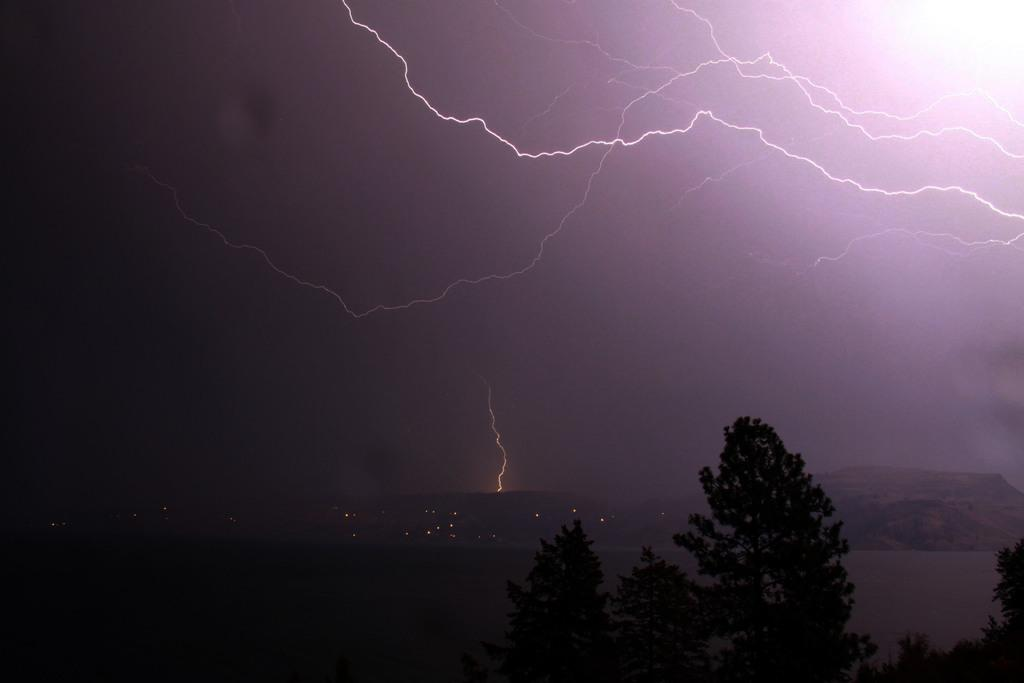What type of natural elements can be seen in the image? There are trees in the image. What type of landscape feature is visible in the distance? There are hills visible in the distance. What type of artificial light sources are present in the image? There are lights in the image. What part of the natural environment is visible in the image? The sky is visible in the image. What weather condition is depicted in the sky? There are thunderstorms in the sky. What is the price of the desk in the image? There is no desk present in the image, so it is not possible to determine its price. 